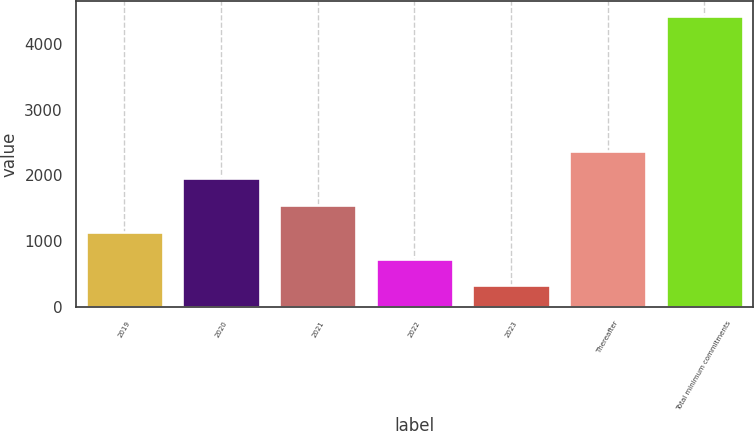<chart> <loc_0><loc_0><loc_500><loc_500><bar_chart><fcel>2019<fcel>2020<fcel>2021<fcel>2022<fcel>2023<fcel>Thereafter<fcel>Total minimum commitments<nl><fcel>1144.6<fcel>1966.2<fcel>1555.4<fcel>733.8<fcel>323<fcel>2377<fcel>4431<nl></chart> 